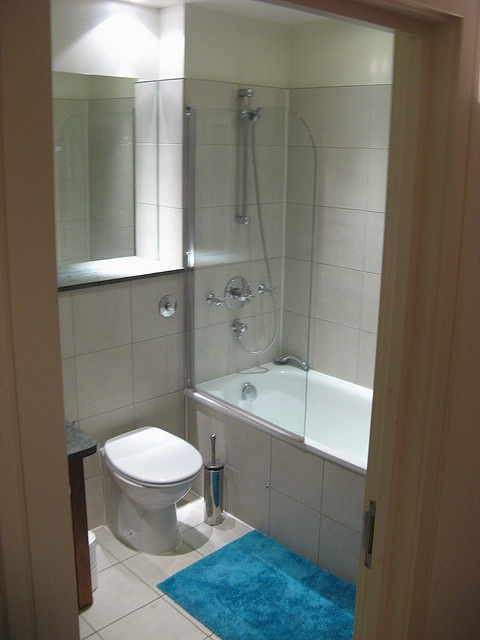Describe the objects in this image and their specific colors. I can see toilet in black, gray, white, and darkgray tones and sink in black, gray, and darkgreen tones in this image. 